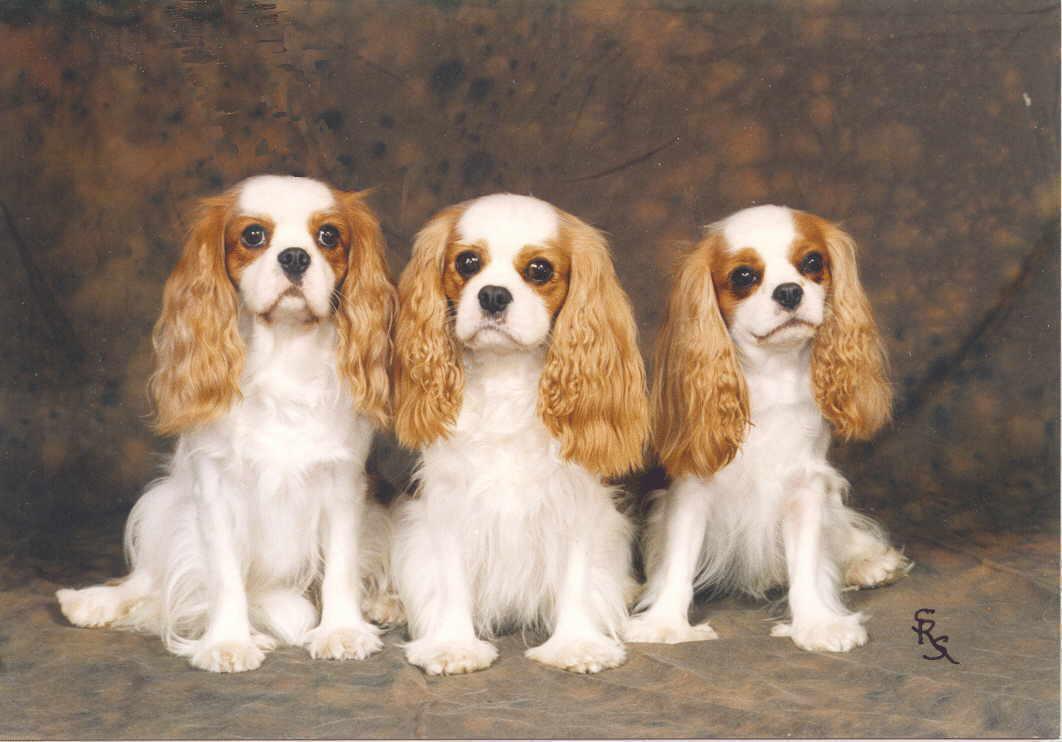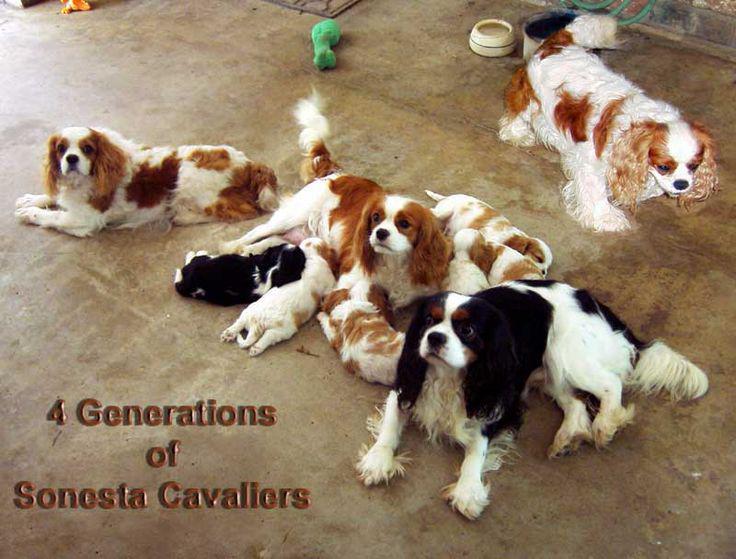The first image is the image on the left, the second image is the image on the right. Considering the images on both sides, is "There are 5 dogs shown." valid? Answer yes or no. No. The first image is the image on the left, the second image is the image on the right. For the images displayed, is the sentence "There are five dogs in total, with more dogs on the right." factually correct? Answer yes or no. No. 